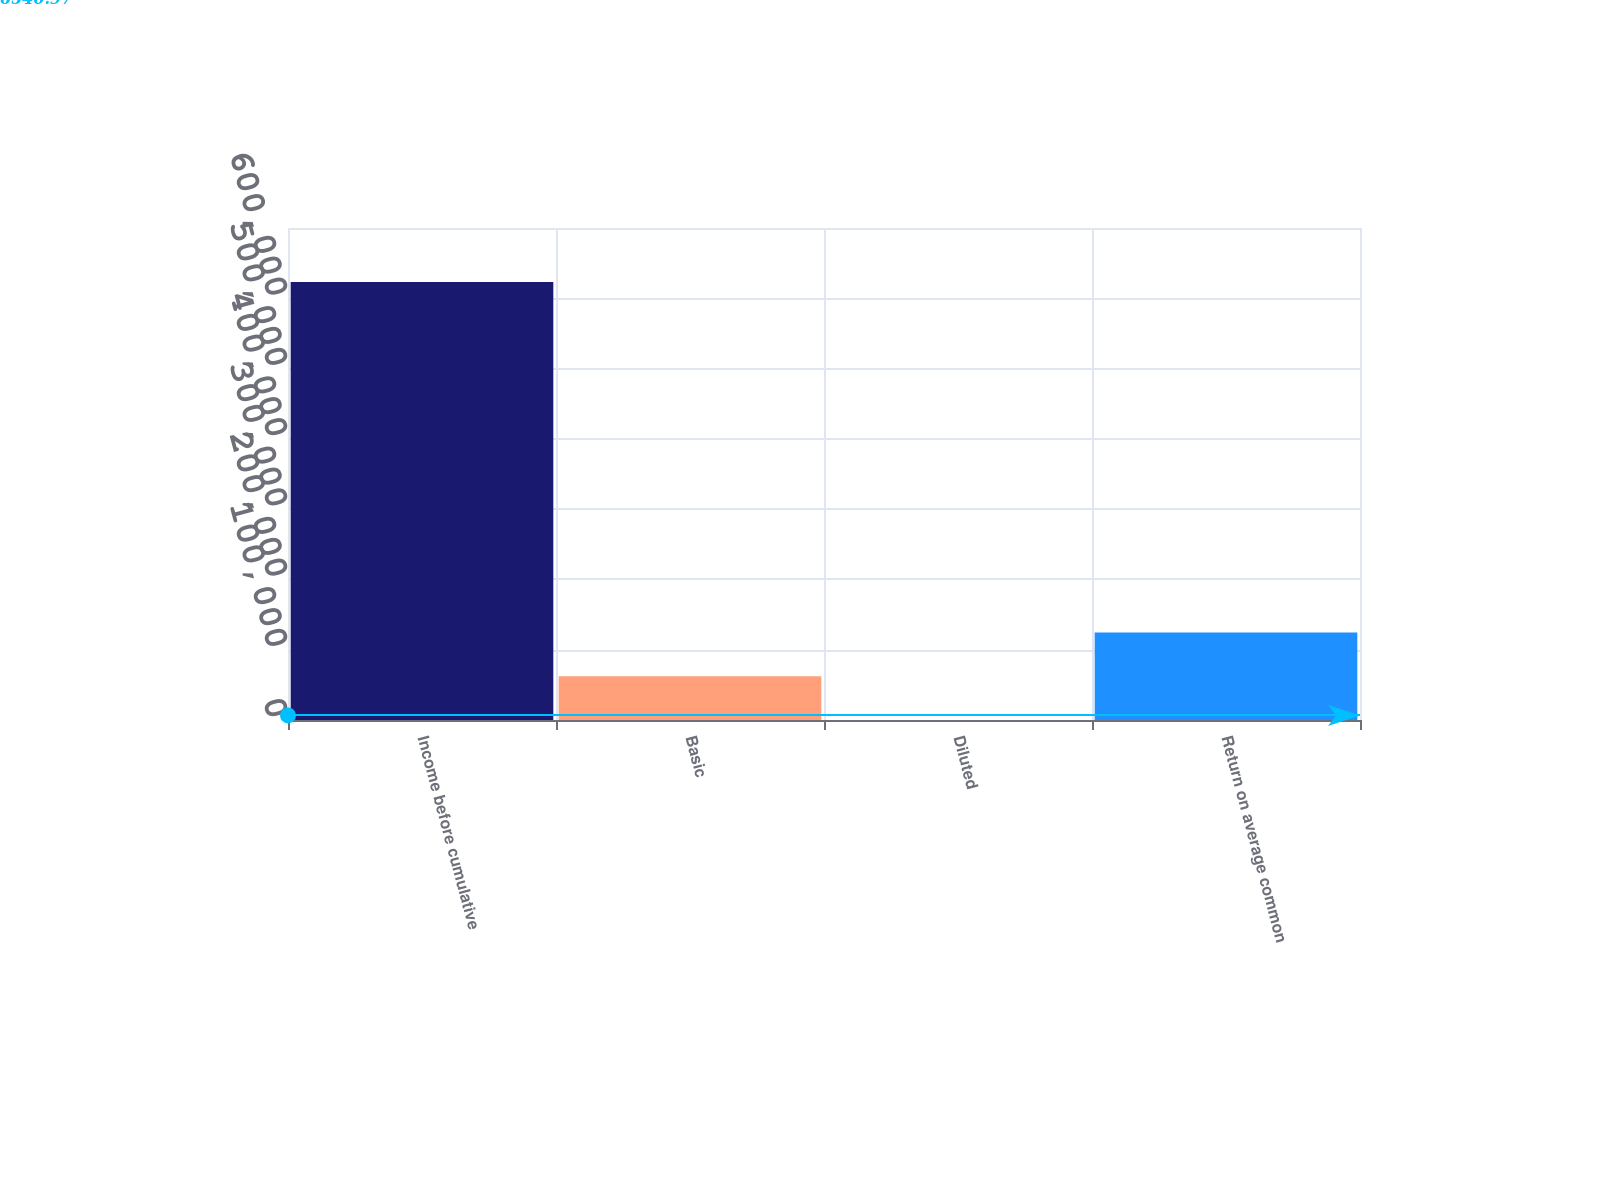<chart> <loc_0><loc_0><loc_500><loc_500><bar_chart><fcel>Income before cumulative<fcel>Basic<fcel>Diluted<fcel>Return on average common<nl><fcel>623072<fcel>62309.6<fcel>2.64<fcel>124617<nl></chart> 